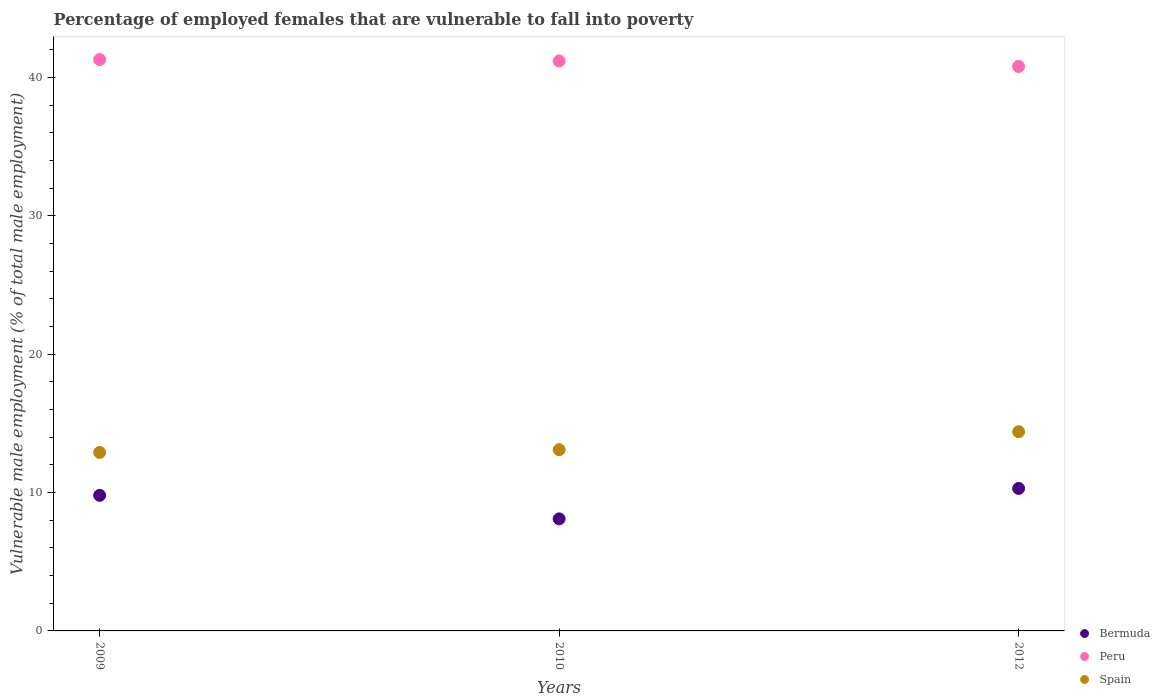How many different coloured dotlines are there?
Your answer should be very brief. 3. What is the percentage of employed females who are vulnerable to fall into poverty in Bermuda in 2010?
Give a very brief answer. 8.1. Across all years, what is the maximum percentage of employed females who are vulnerable to fall into poverty in Bermuda?
Provide a short and direct response. 10.3. Across all years, what is the minimum percentage of employed females who are vulnerable to fall into poverty in Peru?
Your answer should be very brief. 40.8. In which year was the percentage of employed females who are vulnerable to fall into poverty in Bermuda minimum?
Your answer should be very brief. 2010. What is the total percentage of employed females who are vulnerable to fall into poverty in Spain in the graph?
Provide a succinct answer. 40.4. What is the difference between the percentage of employed females who are vulnerable to fall into poverty in Spain in 2009 and that in 2012?
Your response must be concise. -1.5. What is the difference between the percentage of employed females who are vulnerable to fall into poverty in Spain in 2012 and the percentage of employed females who are vulnerable to fall into poverty in Peru in 2009?
Provide a succinct answer. -26.9. What is the average percentage of employed females who are vulnerable to fall into poverty in Bermuda per year?
Offer a terse response. 9.4. In the year 2009, what is the difference between the percentage of employed females who are vulnerable to fall into poverty in Peru and percentage of employed females who are vulnerable to fall into poverty in Bermuda?
Give a very brief answer. 31.5. What is the ratio of the percentage of employed females who are vulnerable to fall into poverty in Spain in 2009 to that in 2012?
Offer a very short reply. 0.9. What is the difference between the highest and the second highest percentage of employed females who are vulnerable to fall into poverty in Peru?
Offer a terse response. 0.1. Is the sum of the percentage of employed females who are vulnerable to fall into poverty in Spain in 2009 and 2012 greater than the maximum percentage of employed females who are vulnerable to fall into poverty in Bermuda across all years?
Your answer should be very brief. Yes. Is the percentage of employed females who are vulnerable to fall into poverty in Spain strictly less than the percentage of employed females who are vulnerable to fall into poverty in Bermuda over the years?
Give a very brief answer. No. What is the difference between two consecutive major ticks on the Y-axis?
Offer a very short reply. 10. Does the graph contain grids?
Offer a terse response. No. How many legend labels are there?
Your answer should be compact. 3. What is the title of the graph?
Provide a short and direct response. Percentage of employed females that are vulnerable to fall into poverty. Does "Bolivia" appear as one of the legend labels in the graph?
Ensure brevity in your answer.  No. What is the label or title of the X-axis?
Keep it short and to the point. Years. What is the label or title of the Y-axis?
Provide a short and direct response. Vulnerable male employment (% of total male employment). What is the Vulnerable male employment (% of total male employment) in Bermuda in 2009?
Make the answer very short. 9.8. What is the Vulnerable male employment (% of total male employment) in Peru in 2009?
Your answer should be very brief. 41.3. What is the Vulnerable male employment (% of total male employment) of Spain in 2009?
Provide a short and direct response. 12.9. What is the Vulnerable male employment (% of total male employment) of Bermuda in 2010?
Provide a short and direct response. 8.1. What is the Vulnerable male employment (% of total male employment) in Peru in 2010?
Ensure brevity in your answer.  41.2. What is the Vulnerable male employment (% of total male employment) of Spain in 2010?
Provide a succinct answer. 13.1. What is the Vulnerable male employment (% of total male employment) of Bermuda in 2012?
Your answer should be compact. 10.3. What is the Vulnerable male employment (% of total male employment) in Peru in 2012?
Provide a short and direct response. 40.8. What is the Vulnerable male employment (% of total male employment) of Spain in 2012?
Make the answer very short. 14.4. Across all years, what is the maximum Vulnerable male employment (% of total male employment) in Bermuda?
Provide a short and direct response. 10.3. Across all years, what is the maximum Vulnerable male employment (% of total male employment) in Peru?
Your response must be concise. 41.3. Across all years, what is the maximum Vulnerable male employment (% of total male employment) of Spain?
Your response must be concise. 14.4. Across all years, what is the minimum Vulnerable male employment (% of total male employment) in Bermuda?
Provide a succinct answer. 8.1. Across all years, what is the minimum Vulnerable male employment (% of total male employment) in Peru?
Make the answer very short. 40.8. Across all years, what is the minimum Vulnerable male employment (% of total male employment) of Spain?
Your answer should be compact. 12.9. What is the total Vulnerable male employment (% of total male employment) in Bermuda in the graph?
Provide a succinct answer. 28.2. What is the total Vulnerable male employment (% of total male employment) in Peru in the graph?
Offer a very short reply. 123.3. What is the total Vulnerable male employment (% of total male employment) of Spain in the graph?
Ensure brevity in your answer.  40.4. What is the difference between the Vulnerable male employment (% of total male employment) of Peru in 2009 and that in 2010?
Keep it short and to the point. 0.1. What is the difference between the Vulnerable male employment (% of total male employment) in Bermuda in 2009 and that in 2012?
Give a very brief answer. -0.5. What is the difference between the Vulnerable male employment (% of total male employment) of Peru in 2009 and that in 2012?
Give a very brief answer. 0.5. What is the difference between the Vulnerable male employment (% of total male employment) of Bermuda in 2009 and the Vulnerable male employment (% of total male employment) of Peru in 2010?
Your answer should be compact. -31.4. What is the difference between the Vulnerable male employment (% of total male employment) in Bermuda in 2009 and the Vulnerable male employment (% of total male employment) in Spain in 2010?
Your response must be concise. -3.3. What is the difference between the Vulnerable male employment (% of total male employment) of Peru in 2009 and the Vulnerable male employment (% of total male employment) of Spain in 2010?
Your response must be concise. 28.2. What is the difference between the Vulnerable male employment (% of total male employment) of Bermuda in 2009 and the Vulnerable male employment (% of total male employment) of Peru in 2012?
Offer a terse response. -31. What is the difference between the Vulnerable male employment (% of total male employment) of Bermuda in 2009 and the Vulnerable male employment (% of total male employment) of Spain in 2012?
Provide a short and direct response. -4.6. What is the difference between the Vulnerable male employment (% of total male employment) in Peru in 2009 and the Vulnerable male employment (% of total male employment) in Spain in 2012?
Your answer should be very brief. 26.9. What is the difference between the Vulnerable male employment (% of total male employment) of Bermuda in 2010 and the Vulnerable male employment (% of total male employment) of Peru in 2012?
Offer a very short reply. -32.7. What is the difference between the Vulnerable male employment (% of total male employment) in Bermuda in 2010 and the Vulnerable male employment (% of total male employment) in Spain in 2012?
Make the answer very short. -6.3. What is the difference between the Vulnerable male employment (% of total male employment) in Peru in 2010 and the Vulnerable male employment (% of total male employment) in Spain in 2012?
Your answer should be very brief. 26.8. What is the average Vulnerable male employment (% of total male employment) in Peru per year?
Provide a short and direct response. 41.1. What is the average Vulnerable male employment (% of total male employment) in Spain per year?
Ensure brevity in your answer.  13.47. In the year 2009, what is the difference between the Vulnerable male employment (% of total male employment) of Bermuda and Vulnerable male employment (% of total male employment) of Peru?
Your answer should be very brief. -31.5. In the year 2009, what is the difference between the Vulnerable male employment (% of total male employment) of Peru and Vulnerable male employment (% of total male employment) of Spain?
Your answer should be compact. 28.4. In the year 2010, what is the difference between the Vulnerable male employment (% of total male employment) of Bermuda and Vulnerable male employment (% of total male employment) of Peru?
Offer a terse response. -33.1. In the year 2010, what is the difference between the Vulnerable male employment (% of total male employment) of Bermuda and Vulnerable male employment (% of total male employment) of Spain?
Your response must be concise. -5. In the year 2010, what is the difference between the Vulnerable male employment (% of total male employment) in Peru and Vulnerable male employment (% of total male employment) in Spain?
Offer a very short reply. 28.1. In the year 2012, what is the difference between the Vulnerable male employment (% of total male employment) in Bermuda and Vulnerable male employment (% of total male employment) in Peru?
Offer a very short reply. -30.5. In the year 2012, what is the difference between the Vulnerable male employment (% of total male employment) in Peru and Vulnerable male employment (% of total male employment) in Spain?
Offer a very short reply. 26.4. What is the ratio of the Vulnerable male employment (% of total male employment) of Bermuda in 2009 to that in 2010?
Provide a succinct answer. 1.21. What is the ratio of the Vulnerable male employment (% of total male employment) in Spain in 2009 to that in 2010?
Your answer should be very brief. 0.98. What is the ratio of the Vulnerable male employment (% of total male employment) in Bermuda in 2009 to that in 2012?
Your answer should be compact. 0.95. What is the ratio of the Vulnerable male employment (% of total male employment) in Peru in 2009 to that in 2012?
Ensure brevity in your answer.  1.01. What is the ratio of the Vulnerable male employment (% of total male employment) of Spain in 2009 to that in 2012?
Keep it short and to the point. 0.9. What is the ratio of the Vulnerable male employment (% of total male employment) in Bermuda in 2010 to that in 2012?
Keep it short and to the point. 0.79. What is the ratio of the Vulnerable male employment (% of total male employment) in Peru in 2010 to that in 2012?
Ensure brevity in your answer.  1.01. What is the ratio of the Vulnerable male employment (% of total male employment) in Spain in 2010 to that in 2012?
Keep it short and to the point. 0.91. What is the difference between the highest and the second highest Vulnerable male employment (% of total male employment) of Bermuda?
Your response must be concise. 0.5. What is the difference between the highest and the second highest Vulnerable male employment (% of total male employment) of Spain?
Give a very brief answer. 1.3. 